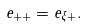<formula> <loc_0><loc_0><loc_500><loc_500>e _ { + + } = e _ { \xi + } .</formula> 